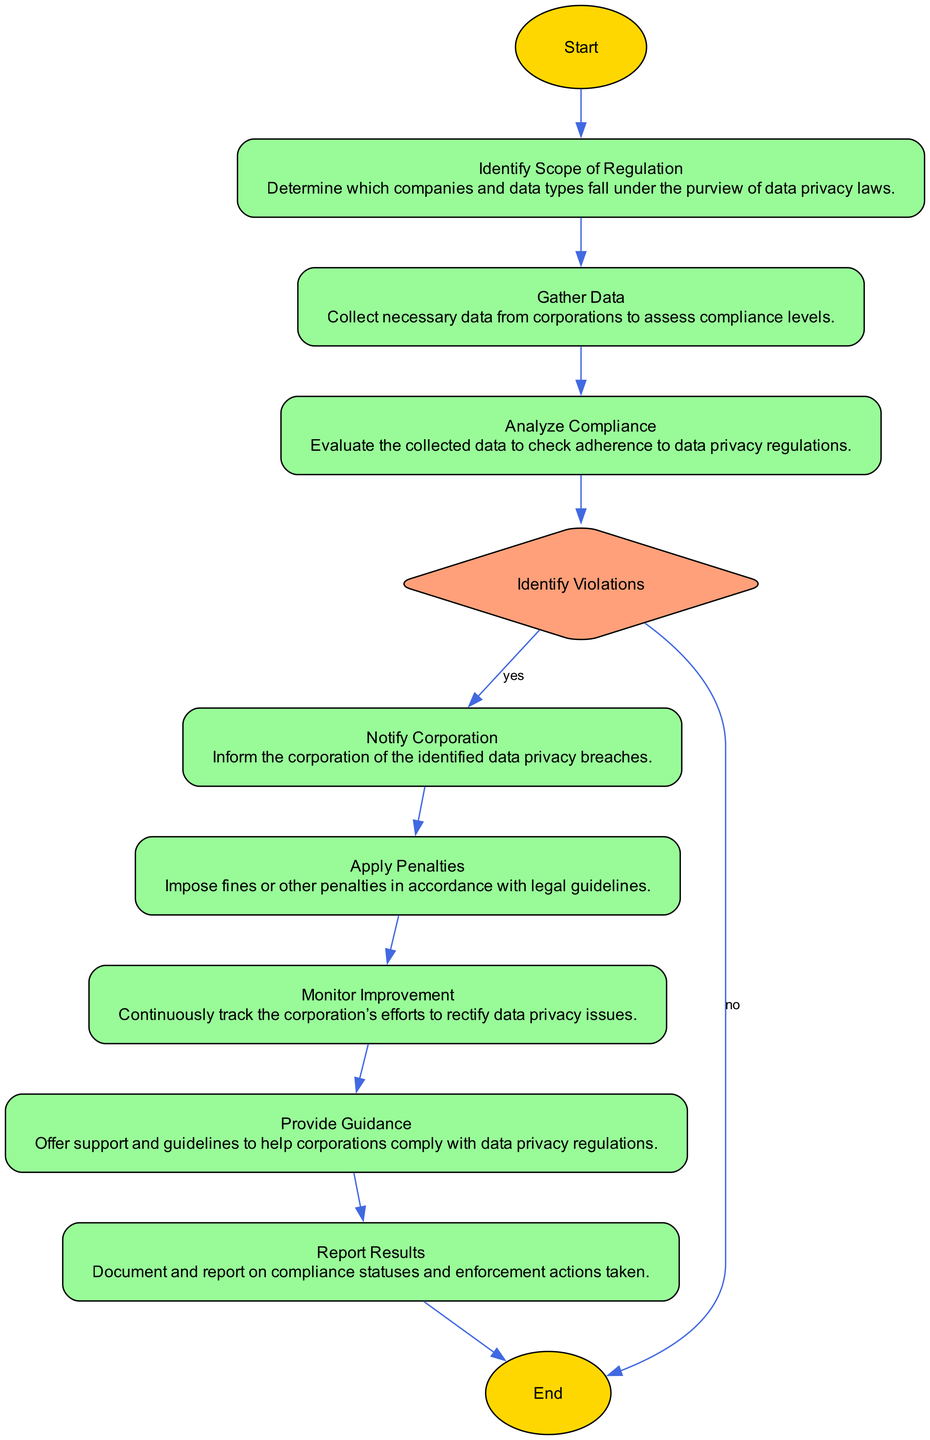What is the first step in the flowchart? The first step in the flowchart is labeled "Start," indicating the beginning of the process for enforcing data privacy regulations.
Answer: Start How many processes are present in the diagram? By reviewing the diagram, we identify the following processes: "Identify Scope of Regulation," "Gather Data," "Analyze Compliance," "Notify Corporation," "Apply Penalties," "Monitor Improvement," and "Provide Guidance," totaling 7 processes.
Answer: 7 What happens after analyzing compliance if there are no violations? If there are no violations after analyzing compliance, the flowchart leads directly to "End," indicating no further action is required in this case.
Answer: End What is the decision made after analyzing compliance? The decision made after analyzing compliance is "Identify Violations," where it is determined whether there are any breaches of data privacy laws or not.
Answer: Identify Violations What process follows the notification of the corporation? Following the notification of the corporation, the next process is "Apply Penalties," which involves imposing fines or other penalties if violations are found.
Answer: Apply Penalties If violations are identified, what is the next step? If violations are identified, the next step is to "Notify Corporation," where the corporation is informed about the data privacy breaches detected during the analysis.
Answer: Notify Corporation How do corporations receive support after violations? Corporations receive support after violations through the "Provide Guidance" process, which offers assistance and guidelines for compliance with data privacy regulations.
Answer: Provide Guidance What action is taken after monitoring improvement? After monitoring improvement, the action taken is to "Report Results," which involves documenting and reporting on the compliance statuses and enforcement actions taken.
Answer: Report Results 